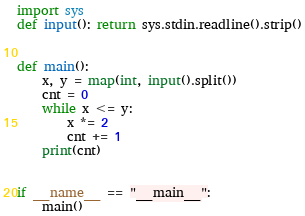<code> <loc_0><loc_0><loc_500><loc_500><_Python_>import sys
def input(): return sys.stdin.readline().strip()


def main():
    x, y = map(int, input().split())
    cnt = 0
    while x <= y:
        x *= 2
        cnt += 1
    print(cnt)


if __name__ == "__main__":
    main()
</code> 